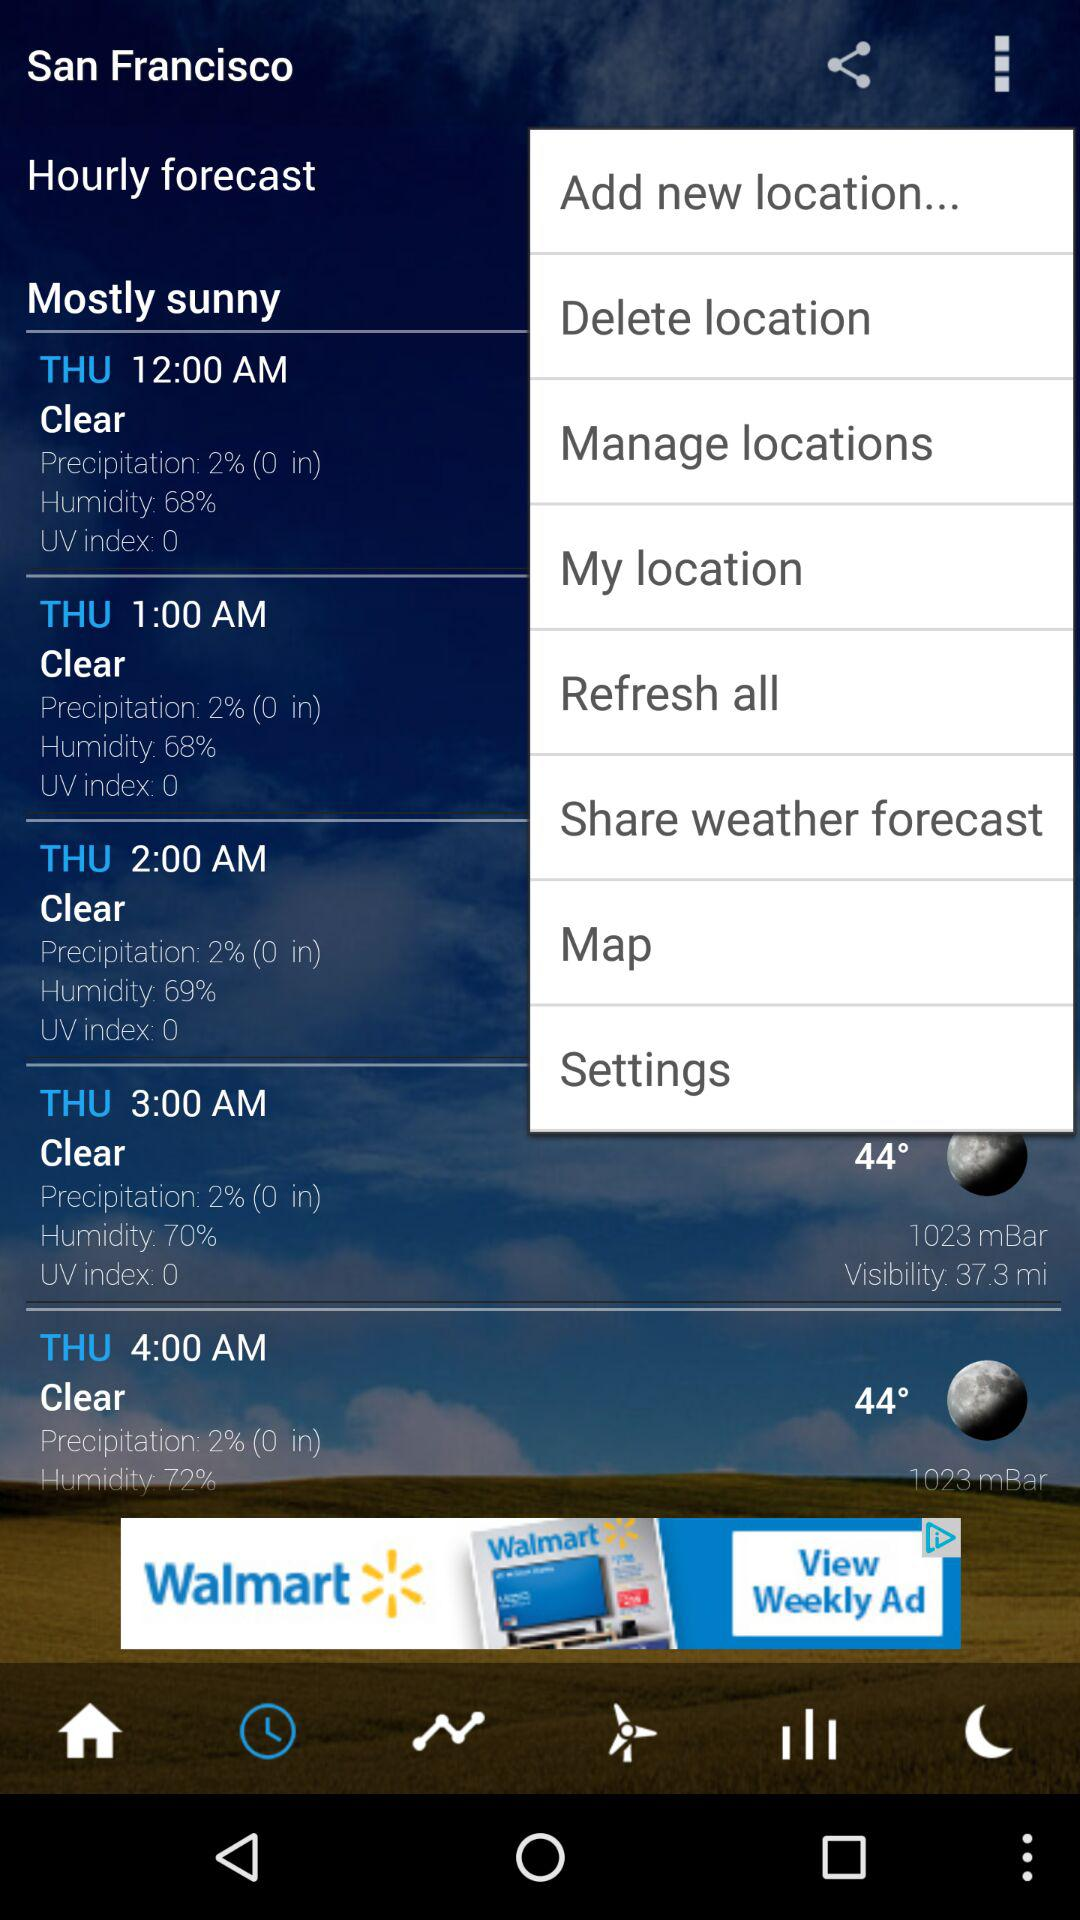What's the humidity percentage at 3 a.m.? The humidity percentage at 3 a.m. is 70. 